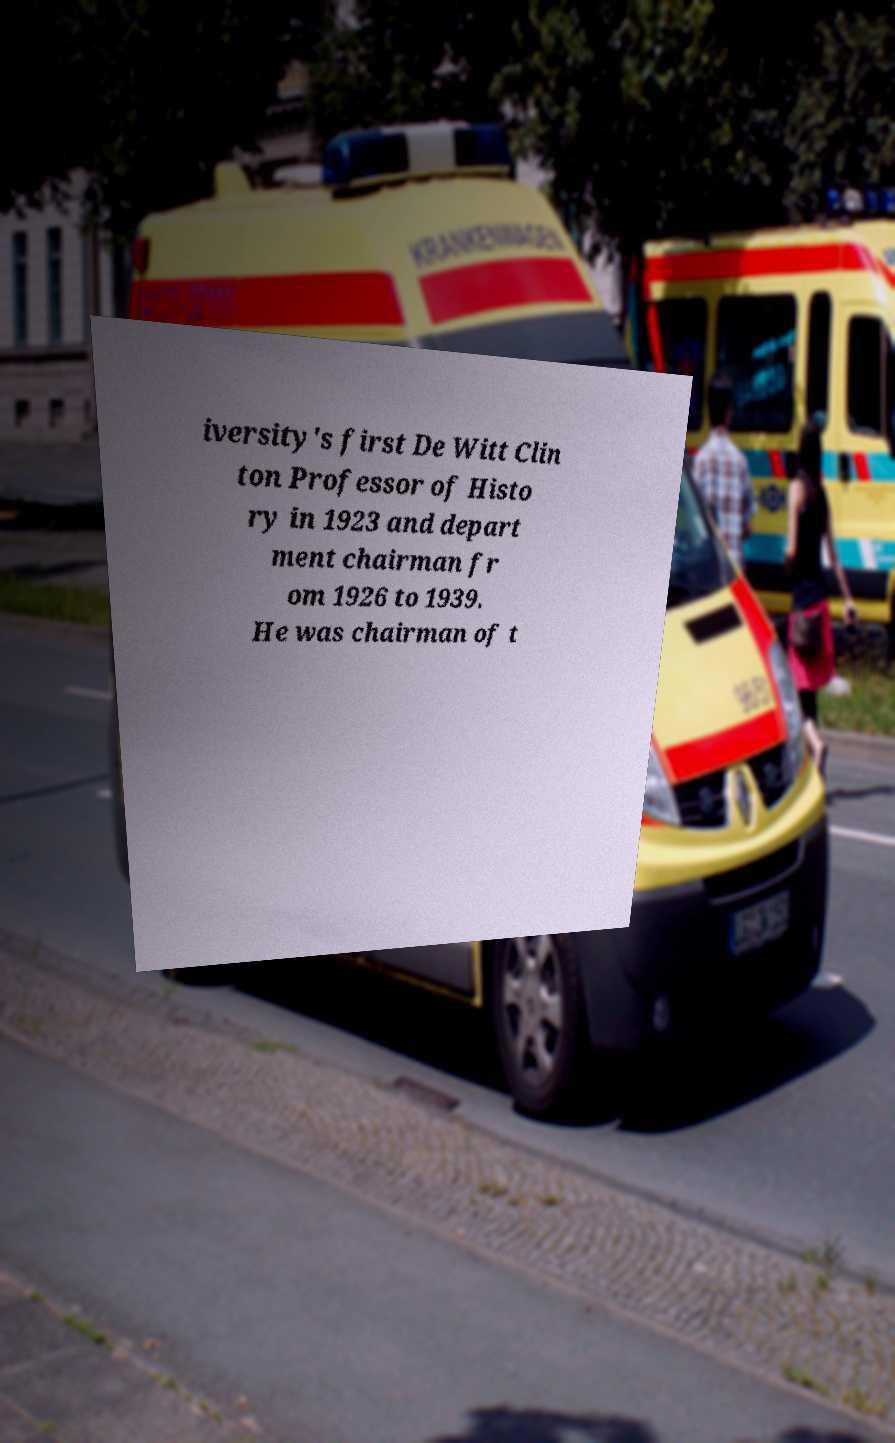Could you assist in decoding the text presented in this image and type it out clearly? iversity's first De Witt Clin ton Professor of Histo ry in 1923 and depart ment chairman fr om 1926 to 1939. He was chairman of t 